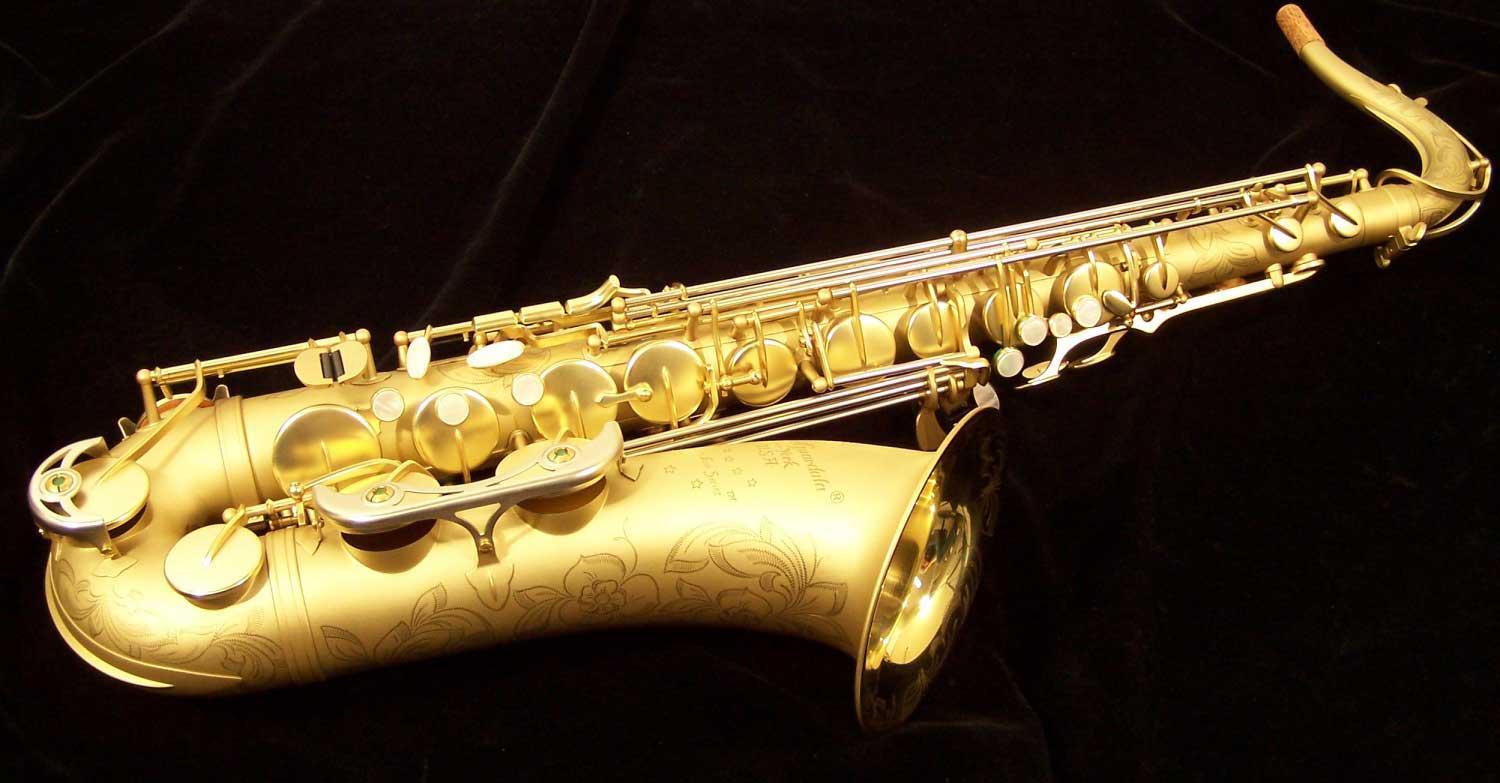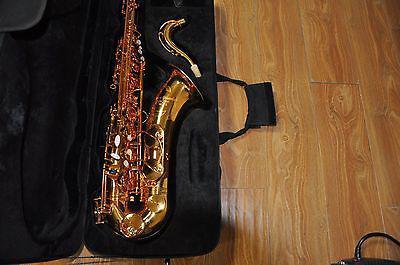The first image is the image on the left, the second image is the image on the right. Analyze the images presented: Is the assertion "An image shows a gold-colored saxophone with floral etchings on the bell and a non-shiny exterior finish, displayed on black without wrinkles." valid? Answer yes or no. Yes. 